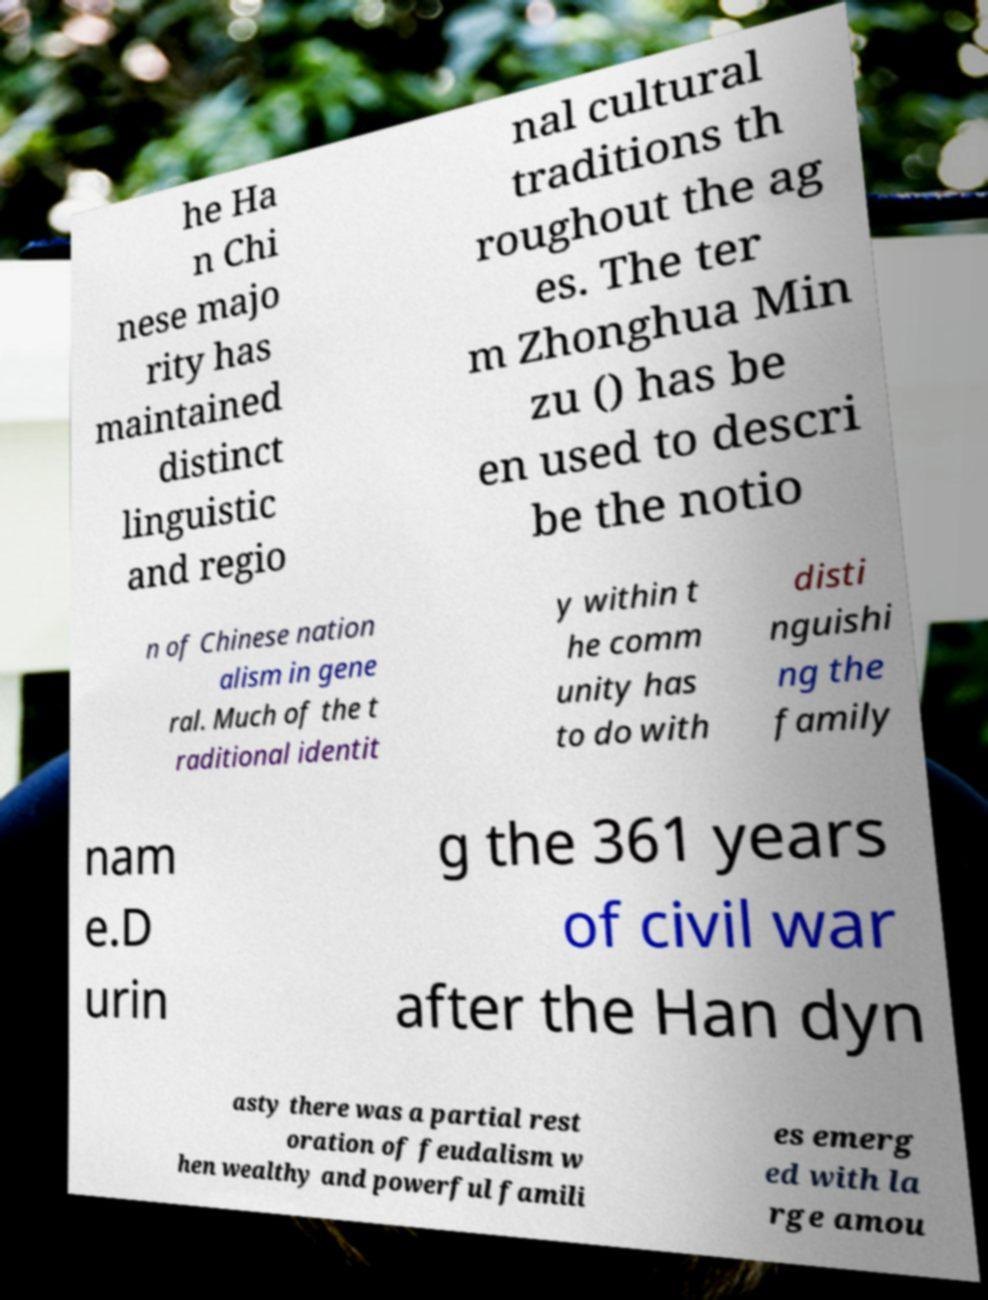Could you assist in decoding the text presented in this image and type it out clearly? he Ha n Chi nese majo rity has maintained distinct linguistic and regio nal cultural traditions th roughout the ag es. The ter m Zhonghua Min zu () has be en used to descri be the notio n of Chinese nation alism in gene ral. Much of the t raditional identit y within t he comm unity has to do with disti nguishi ng the family nam e.D urin g the 361 years of civil war after the Han dyn asty there was a partial rest oration of feudalism w hen wealthy and powerful famili es emerg ed with la rge amou 